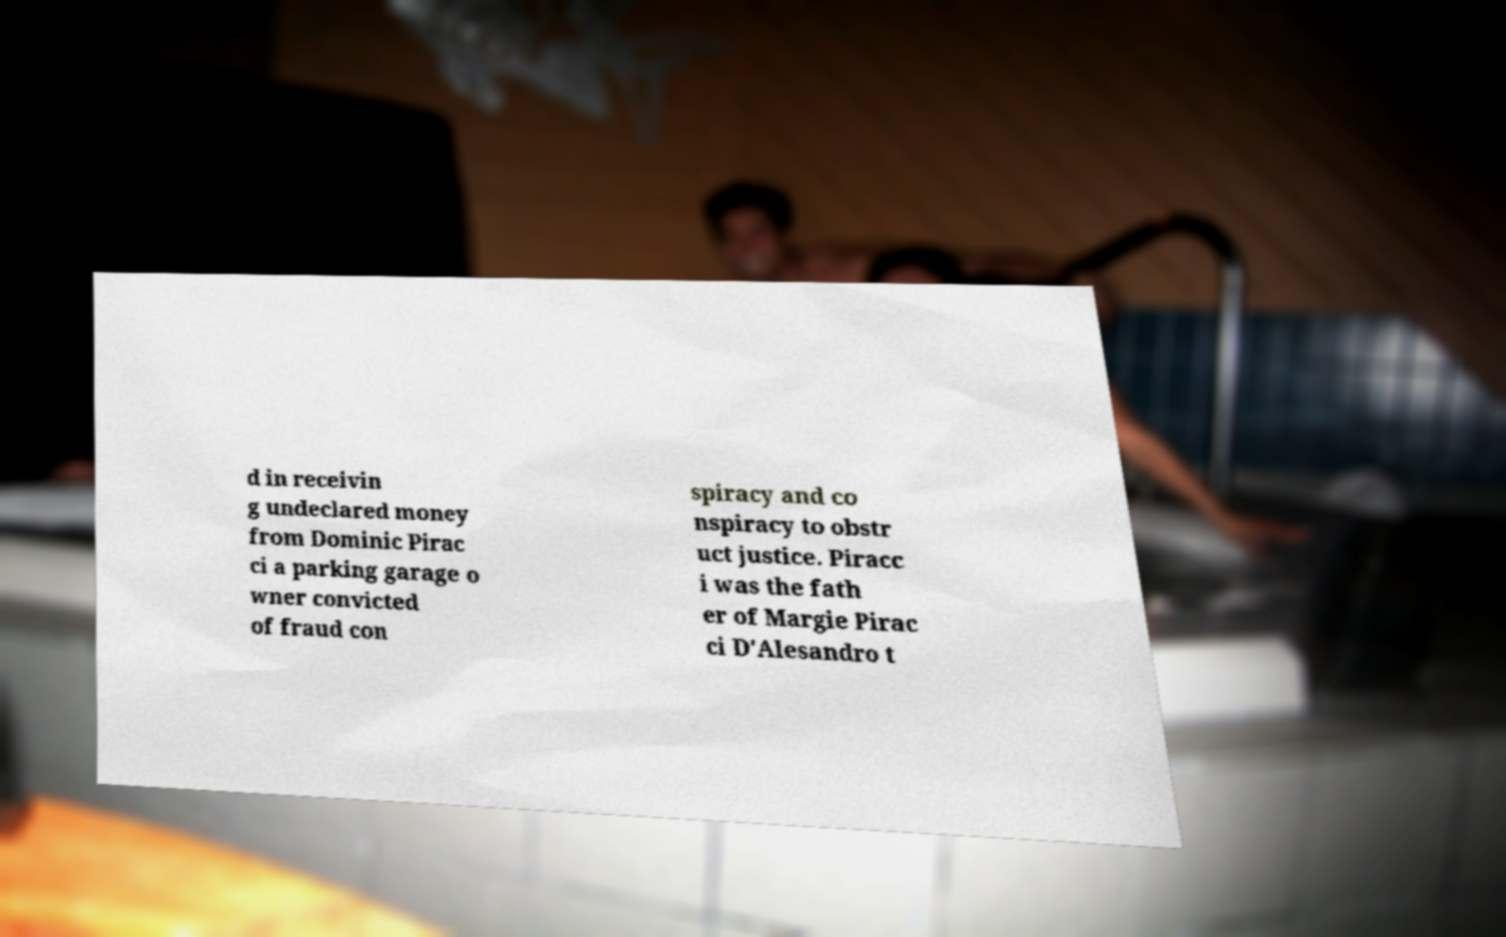Please identify and transcribe the text found in this image. d in receivin g undeclared money from Dominic Pirac ci a parking garage o wner convicted of fraud con spiracy and co nspiracy to obstr uct justice. Piracc i was the fath er of Margie Pirac ci D'Alesandro t 